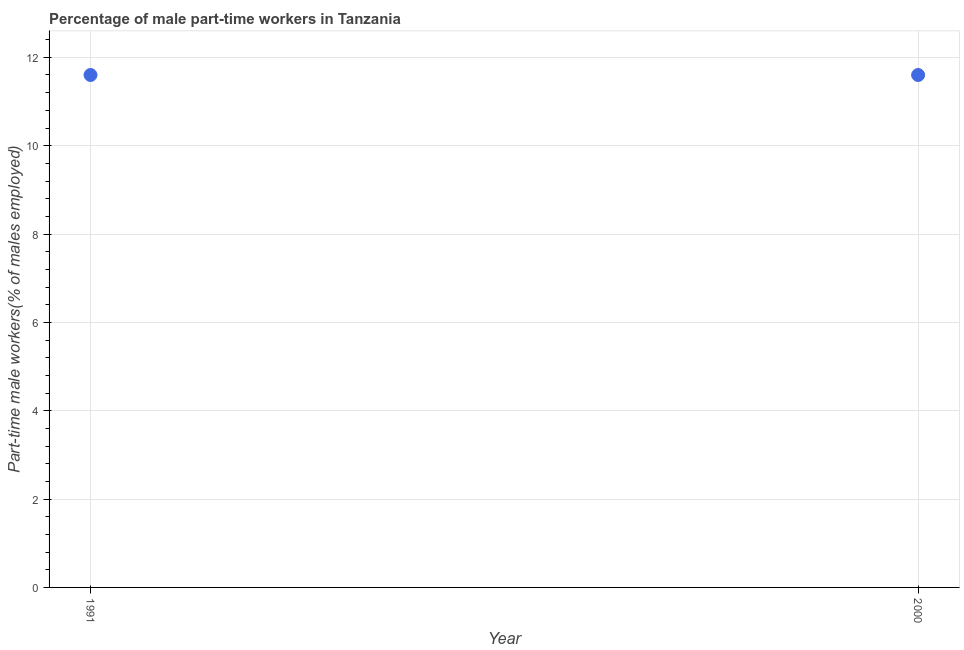What is the percentage of part-time male workers in 2000?
Give a very brief answer. 11.6. Across all years, what is the maximum percentage of part-time male workers?
Provide a succinct answer. 11.6. Across all years, what is the minimum percentage of part-time male workers?
Provide a short and direct response. 11.6. In which year was the percentage of part-time male workers maximum?
Provide a short and direct response. 1991. What is the sum of the percentage of part-time male workers?
Your answer should be compact. 23.2. What is the difference between the percentage of part-time male workers in 1991 and 2000?
Offer a terse response. 0. What is the average percentage of part-time male workers per year?
Provide a succinct answer. 11.6. What is the median percentage of part-time male workers?
Keep it short and to the point. 11.6. Do a majority of the years between 1991 and 2000 (inclusive) have percentage of part-time male workers greater than 10.8 %?
Keep it short and to the point. Yes. What is the ratio of the percentage of part-time male workers in 1991 to that in 2000?
Your response must be concise. 1. Is the percentage of part-time male workers in 1991 less than that in 2000?
Your answer should be very brief. No. How many dotlines are there?
Make the answer very short. 1. How many years are there in the graph?
Your response must be concise. 2. What is the difference between two consecutive major ticks on the Y-axis?
Your response must be concise. 2. Are the values on the major ticks of Y-axis written in scientific E-notation?
Keep it short and to the point. No. What is the title of the graph?
Provide a short and direct response. Percentage of male part-time workers in Tanzania. What is the label or title of the Y-axis?
Give a very brief answer. Part-time male workers(% of males employed). What is the Part-time male workers(% of males employed) in 1991?
Ensure brevity in your answer.  11.6. What is the Part-time male workers(% of males employed) in 2000?
Keep it short and to the point. 11.6. What is the difference between the Part-time male workers(% of males employed) in 1991 and 2000?
Provide a short and direct response. 0. What is the ratio of the Part-time male workers(% of males employed) in 1991 to that in 2000?
Your response must be concise. 1. 